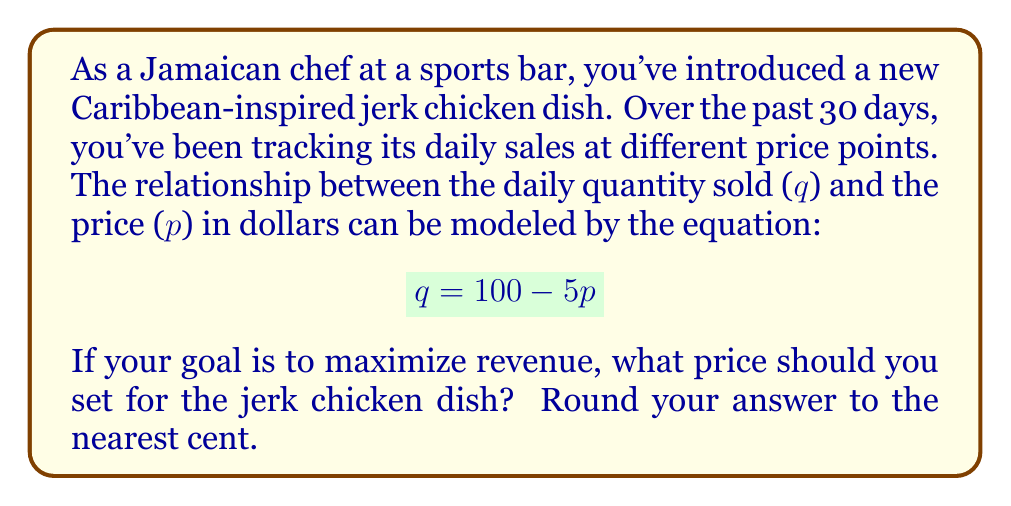What is the answer to this math problem? To solve this problem, we need to follow these steps:

1) Revenue ($R$) is calculated by multiplying price ($p$) by quantity sold ($q$):

   $$ R = p \cdot q $$

2) Substitute the given equation for $q$ into the revenue equation:

   $$ R = p \cdot (100 - 5p) = 100p - 5p^2 $$

3) To find the maximum revenue, we need to find the vertex of this quadratic function. We can do this by finding where the derivative of $R$ with respect to $p$ equals zero:

   $$ \frac{dR}{dp} = 100 - 10p $$

4) Set this equal to zero and solve for $p$:

   $$ 100 - 10p = 0 $$
   $$ -10p = -100 $$
   $$ p = 10 $$

5) To confirm this is a maximum (not a minimum), we can check that the second derivative is negative:

   $$ \frac{d^2R}{dp^2} = -10 $$

   Since this is negative, we confirm that $p = 10$ gives us the maximum revenue.

6) Therefore, the optimal price for maximizing revenue is $10.00.
Answer: $10.00 